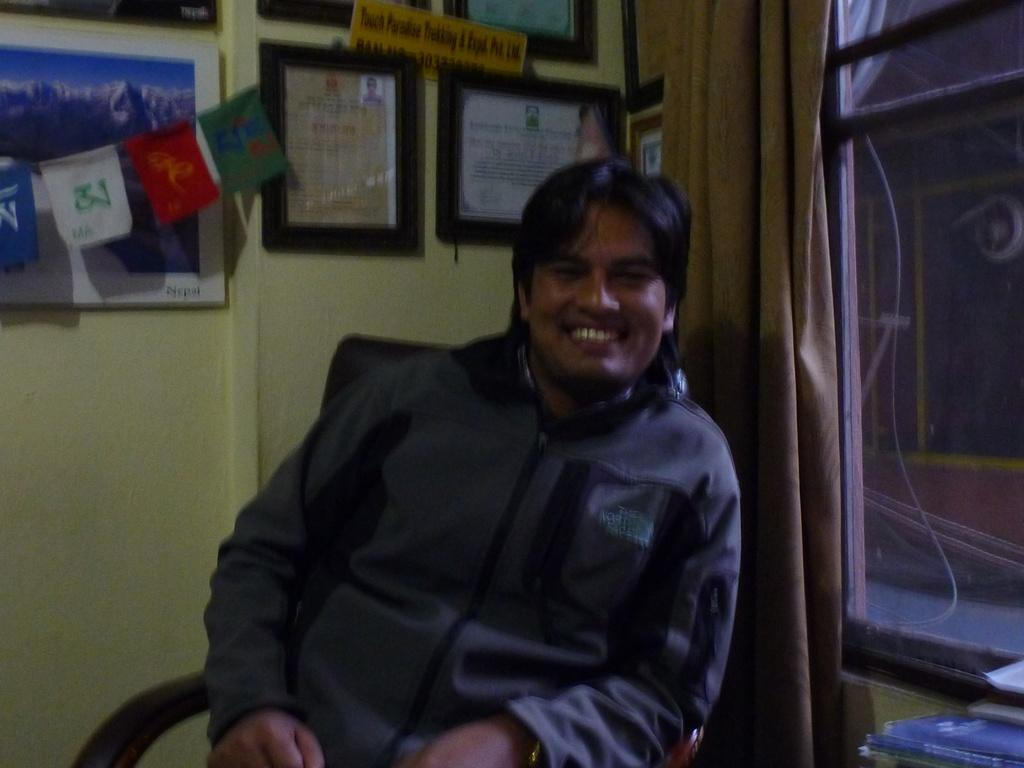What is the man in the image doing? The man is sitting in the image. What is the man's facial expression? The man is smiling. What can be seen in the background of the image? There are flags, frames on the wall, a curtain, and a window in the background. What type of music is the man playing in the image? There is no indication in the image that the man is playing music, so it cannot be determined from the picture. 